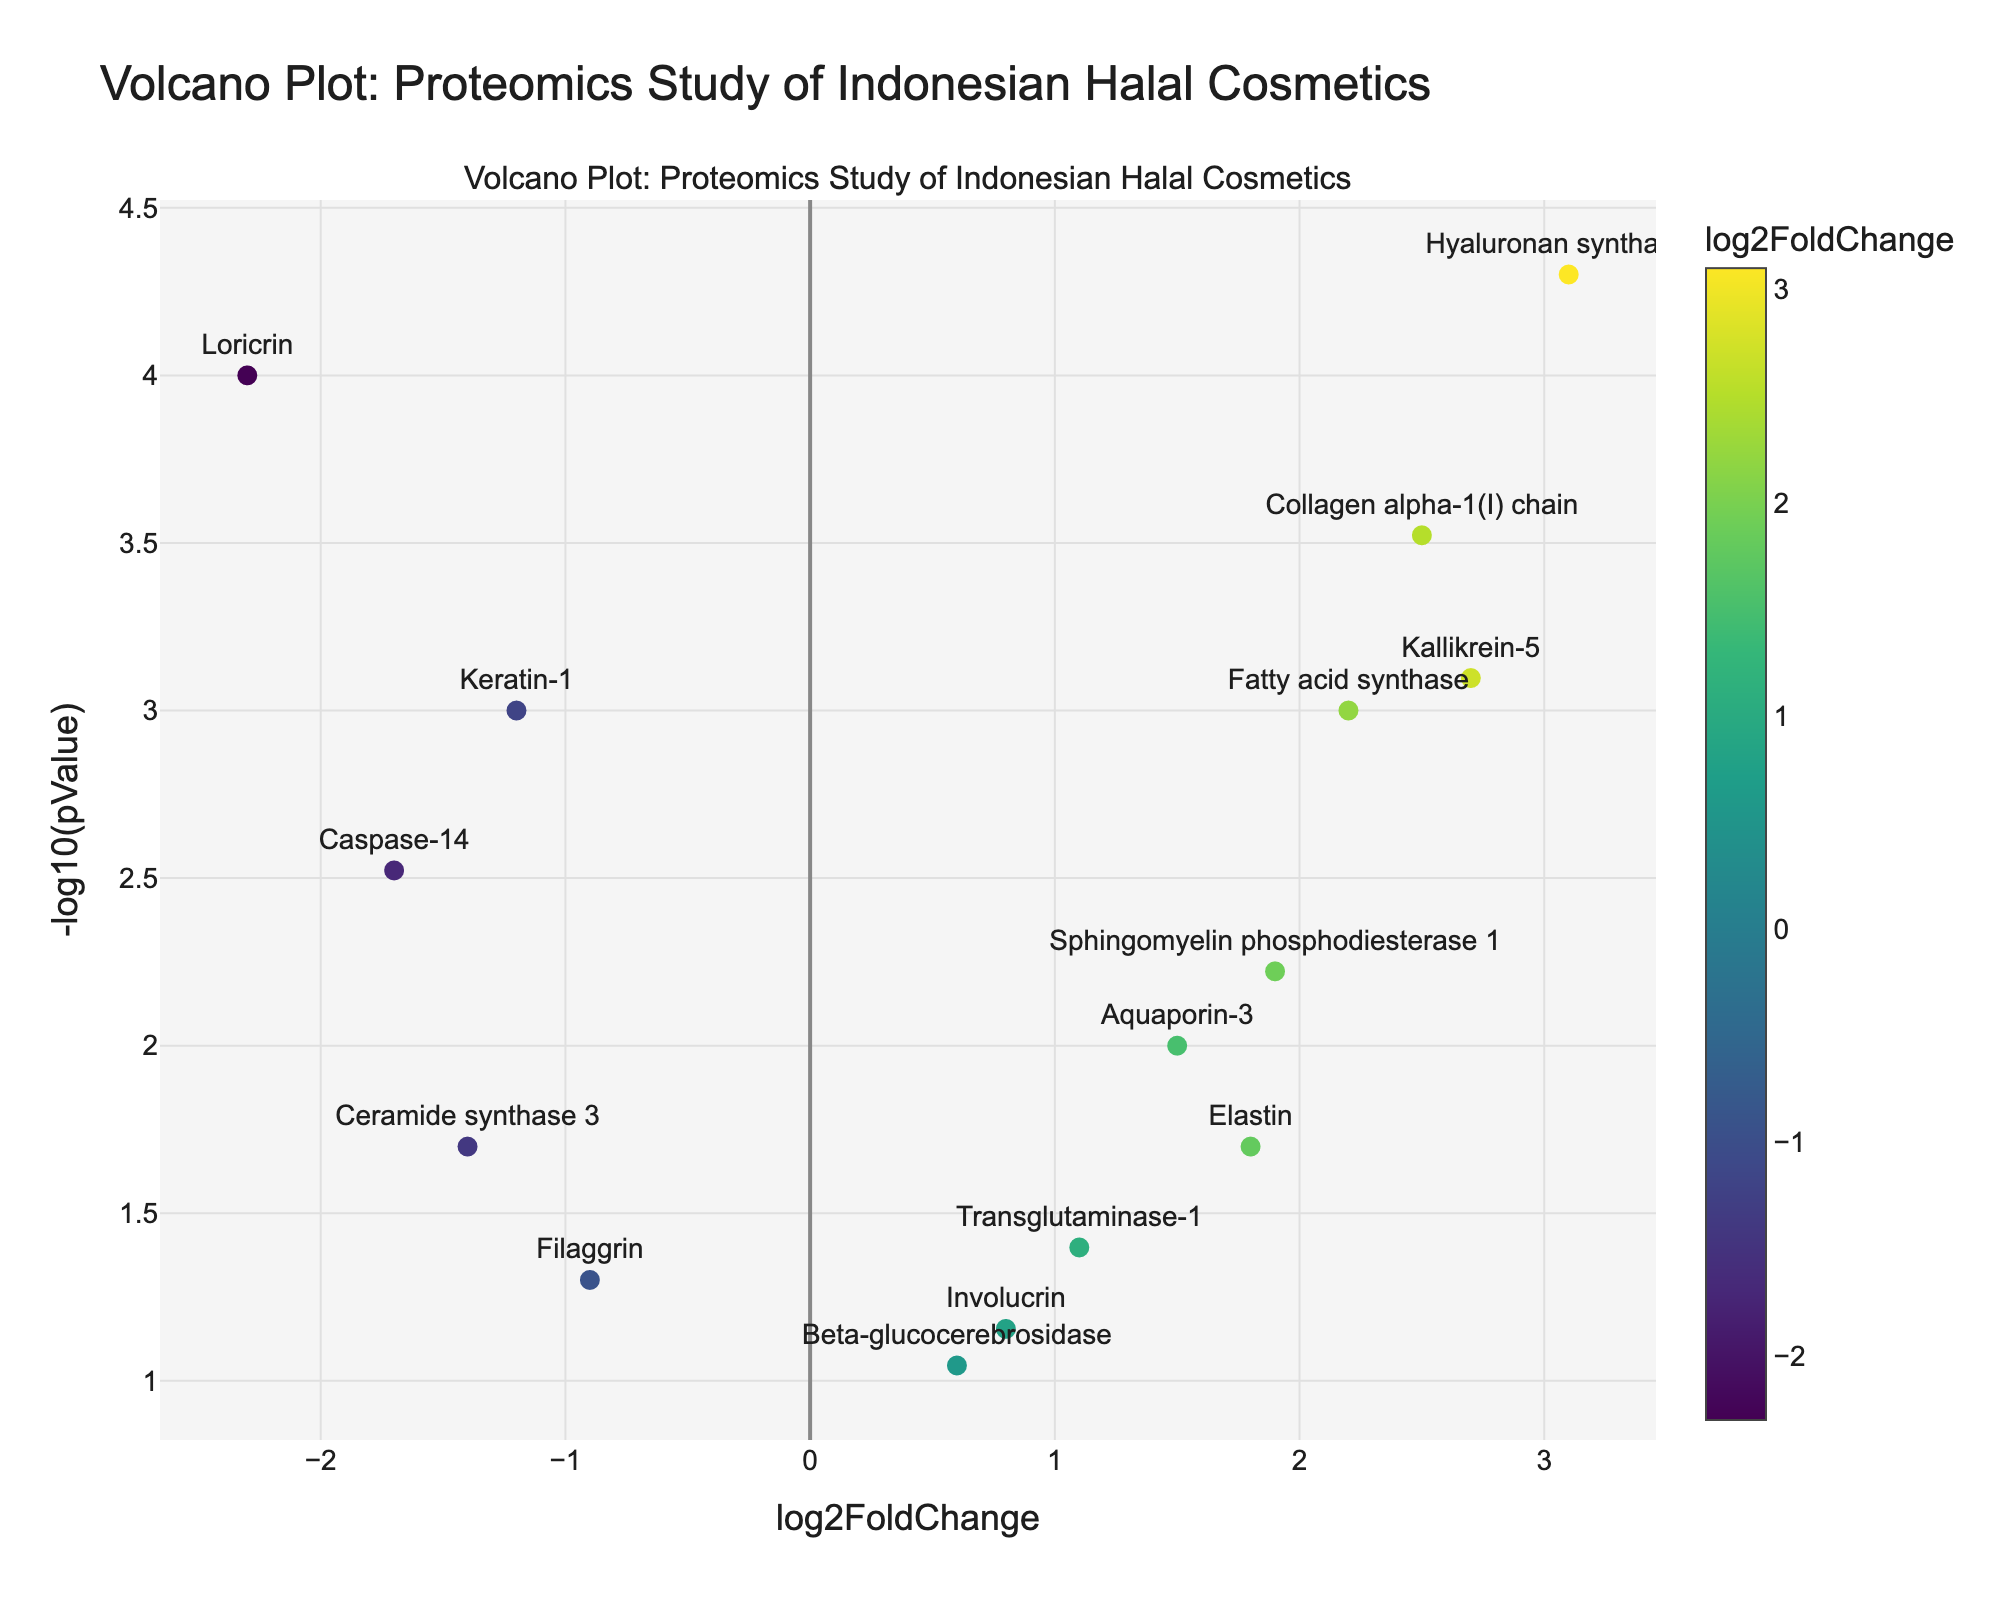What is the title of the figure? The title of the figure is located at the top and clearly labeled.
Answer: Volcano Plot: Proteomics Study of Indonesian Halal Cosmetics Which protein has the highest log2FoldChange? By examining the x-axis values, Hyaluronan synthase 2 has the highest log2FoldChange.
Answer: Hyaluronan synthase 2 What is the y-axis representing in the plot? The y-axis represents -log10(pValue), showing the statistical significance of the protein expressions.
Answer: -log10(pValue) Which protein is significantly down-regulated with the greatest fold change? The most down-regulated protein is Loricrin with a negative log2FoldChange and is farthest to the left on the x-axis.
Answer: Loricrin How many proteins have a pValue less than 0.001? Look at the y-axis and count the proteins with log10(pValue) greater than 3.
Answer: 5 Which proteins have a log2FoldChange greater than 2? Consult the x-axis for values greater than 2 and identify the proteins. These are Collagen alpha-1(I) chain, Kallikrein-5, and Fatty acid synthase.
Answer: Collagen alpha-1(I) chain, Kallikrein-5, Fatty acid synthase Compare the statistical significance of Aquaporin-3 and Elastin. Which one is more significant? Check the y-axis values for both proteins; the higher the -log10(pValue), the more significant the result. Aquaporin-3 has a higher -log10(pValue) than Elastin.
Answer: Aquaporin-3 What is the log2FoldChange of Caspase-14 and Sphingomyelin phosphodiesterase 1? Locate the x-axis values for both proteins. Caspase-14 has a log2FoldChange of -1.7, and Sphingomyelin phosphodiesterase 1 has a log2FoldChange of 1.9.
Answer: Caspase-14: -1.7, Sphingomyelin phosphodiesterase 1: 1.9 Which protein shows a fold-change close to 0 and has a pValue around the significance threshold? Proteins close to the center vertically and near 0 on the x-axis are the ones in question. Involucrin fits this description.
Answer: Involucrin How many proteins are up-regulated (log2FoldChange > 0) and have pValues less than 0.01? Identify proteins to the right of the origin (log2FoldChange > 0) and with -log10(pValue) greater than 2. There are 5 such points: Collagen alpha-1(I) chain, Hyaluronan synthase 2, Aquaporin-3, Kallikrein-5, and Sphingomyelin phosphodiesterase 1.
Answer: 5 